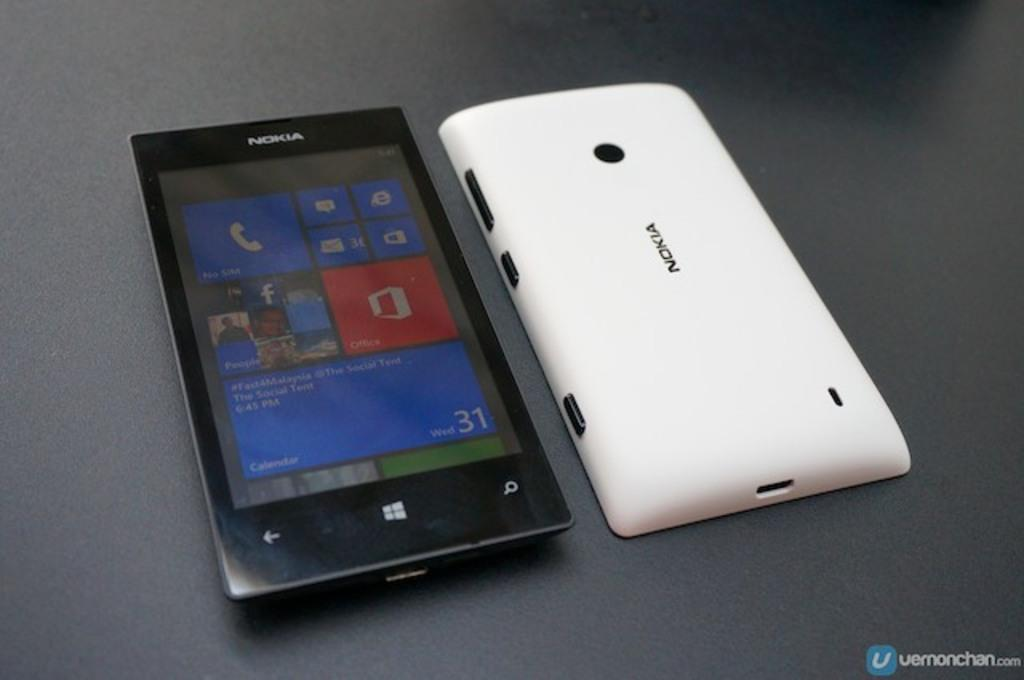<image>
Provide a brief description of the given image. a nokia phone next to a white case that says nokia on it 